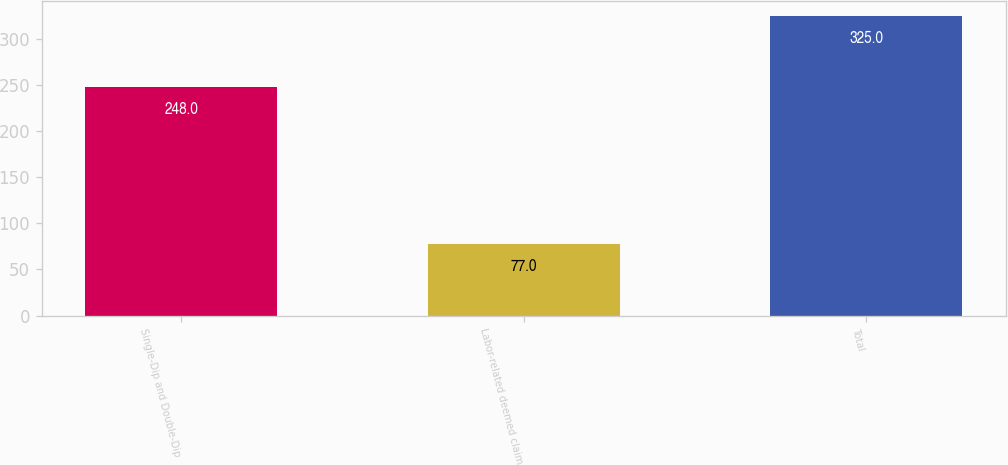Convert chart. <chart><loc_0><loc_0><loc_500><loc_500><bar_chart><fcel>Single-Dip and Double-Dip<fcel>Labor-related deemed claim<fcel>Total<nl><fcel>248<fcel>77<fcel>325<nl></chart> 